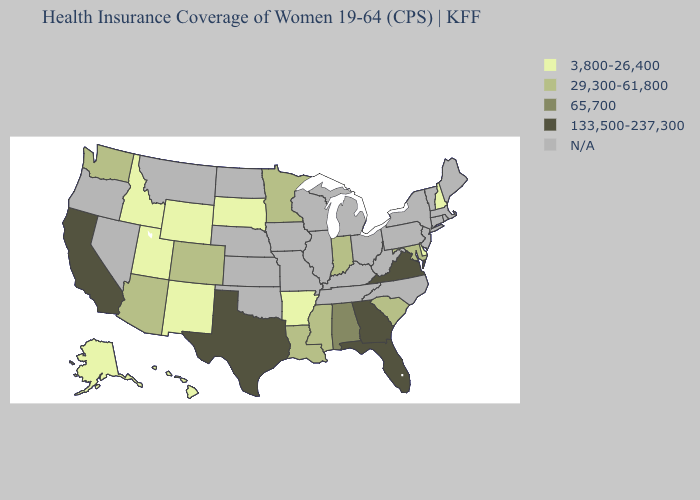What is the lowest value in the South?
Short answer required. 3,800-26,400. What is the highest value in the South ?
Be succinct. 133,500-237,300. What is the value of Massachusetts?
Give a very brief answer. N/A. Is the legend a continuous bar?
Answer briefly. No. What is the value of New Mexico?
Be succinct. 3,800-26,400. Name the states that have a value in the range 3,800-26,400?
Be succinct. Alaska, Arkansas, Delaware, Hawaii, Idaho, New Hampshire, New Mexico, South Dakota, Utah, Wyoming. What is the value of South Carolina?
Write a very short answer. 29,300-61,800. What is the value of New Hampshire?
Short answer required. 3,800-26,400. Is the legend a continuous bar?
Keep it brief. No. Which states have the lowest value in the South?
Answer briefly. Arkansas, Delaware. Which states have the lowest value in the Northeast?
Short answer required. New Hampshire. Which states have the highest value in the USA?
Write a very short answer. California, Florida, Georgia, Texas, Virginia. What is the value of Arizona?
Answer briefly. 29,300-61,800. What is the value of Delaware?
Be succinct. 3,800-26,400. 